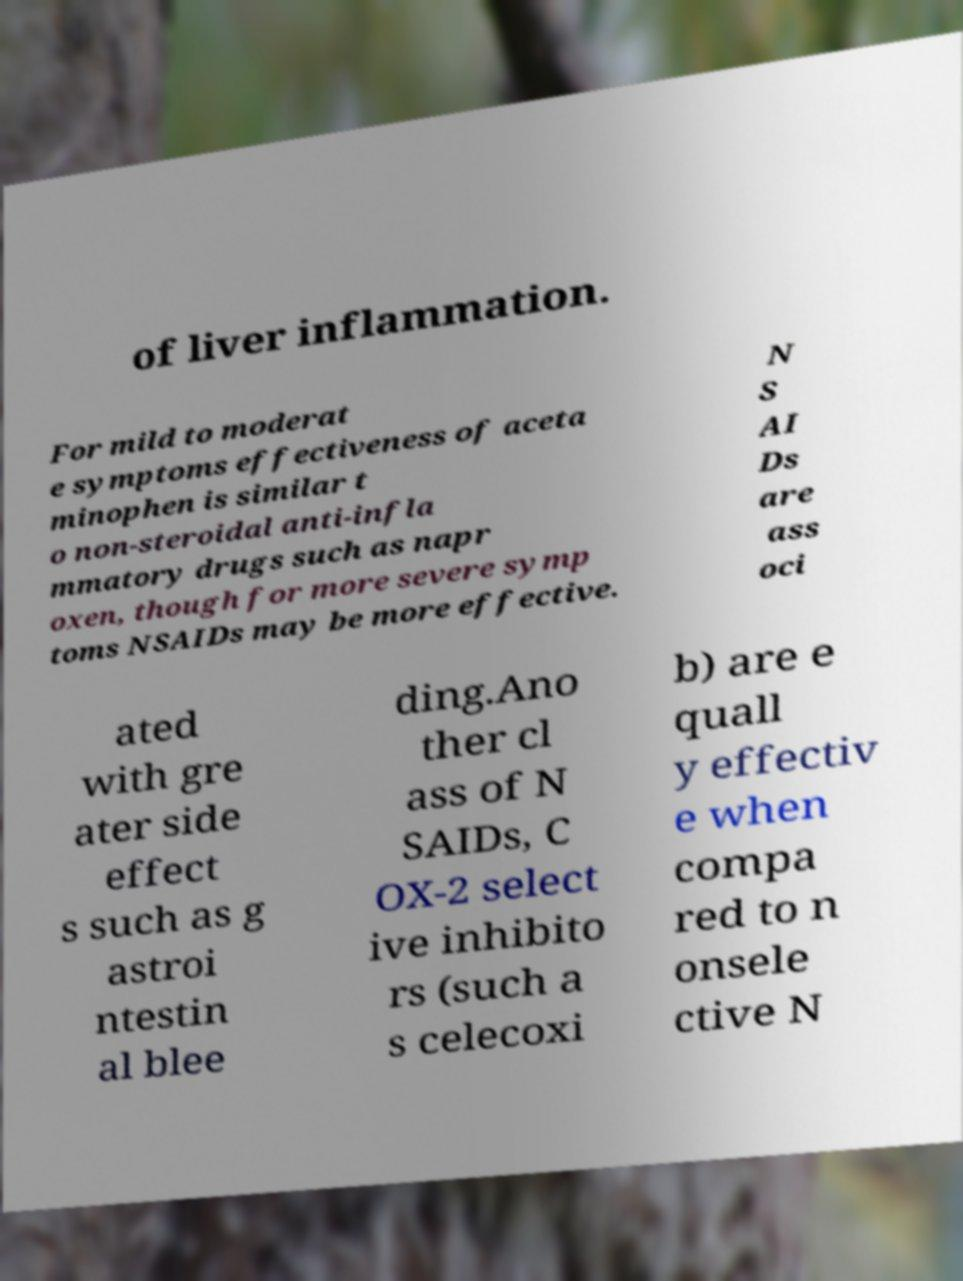Can you accurately transcribe the text from the provided image for me? of liver inflammation. For mild to moderat e symptoms effectiveness of aceta minophen is similar t o non-steroidal anti-infla mmatory drugs such as napr oxen, though for more severe symp toms NSAIDs may be more effective. N S AI Ds are ass oci ated with gre ater side effect s such as g astroi ntestin al blee ding.Ano ther cl ass of N SAIDs, C OX-2 select ive inhibito rs (such a s celecoxi b) are e quall y effectiv e when compa red to n onsele ctive N 